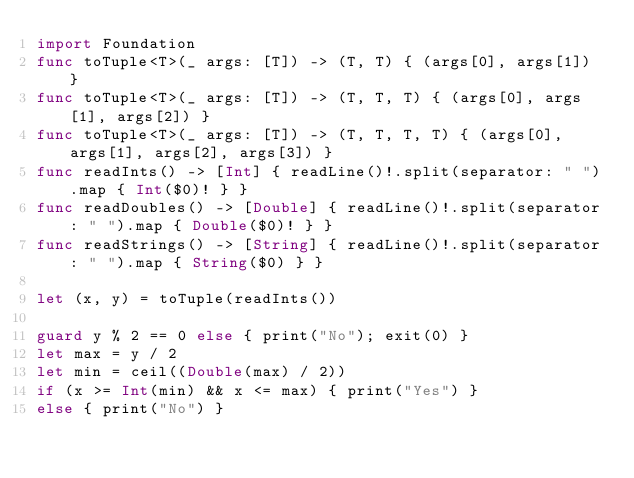Convert code to text. <code><loc_0><loc_0><loc_500><loc_500><_Swift_>import Foundation
func toTuple<T>(_ args: [T]) -> (T, T) { (args[0], args[1]) }
func toTuple<T>(_ args: [T]) -> (T, T, T) { (args[0], args[1], args[2]) }
func toTuple<T>(_ args: [T]) -> (T, T, T, T) { (args[0], args[1], args[2], args[3]) }
func readInts() -> [Int] { readLine()!.split(separator: " ").map { Int($0)! } }
func readDoubles() -> [Double] { readLine()!.split(separator: " ").map { Double($0)! } }
func readStrings() -> [String] { readLine()!.split(separator: " ").map { String($0) } }

let (x, y) = toTuple(readInts())

guard y % 2 == 0 else { print("No"); exit(0) }
let max = y / 2
let min = ceil((Double(max) / 2))
if (x >= Int(min) && x <= max) { print("Yes") }
else { print("No") }</code> 